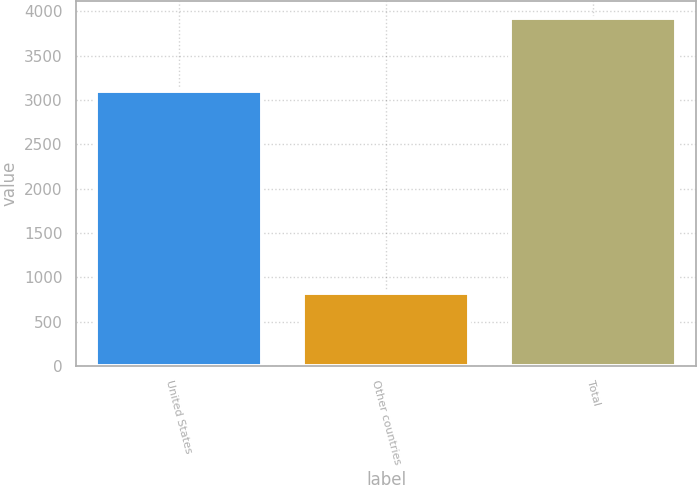<chart> <loc_0><loc_0><loc_500><loc_500><bar_chart><fcel>United States<fcel>Other countries<fcel>Total<nl><fcel>3099.9<fcel>824.8<fcel>3924.7<nl></chart> 